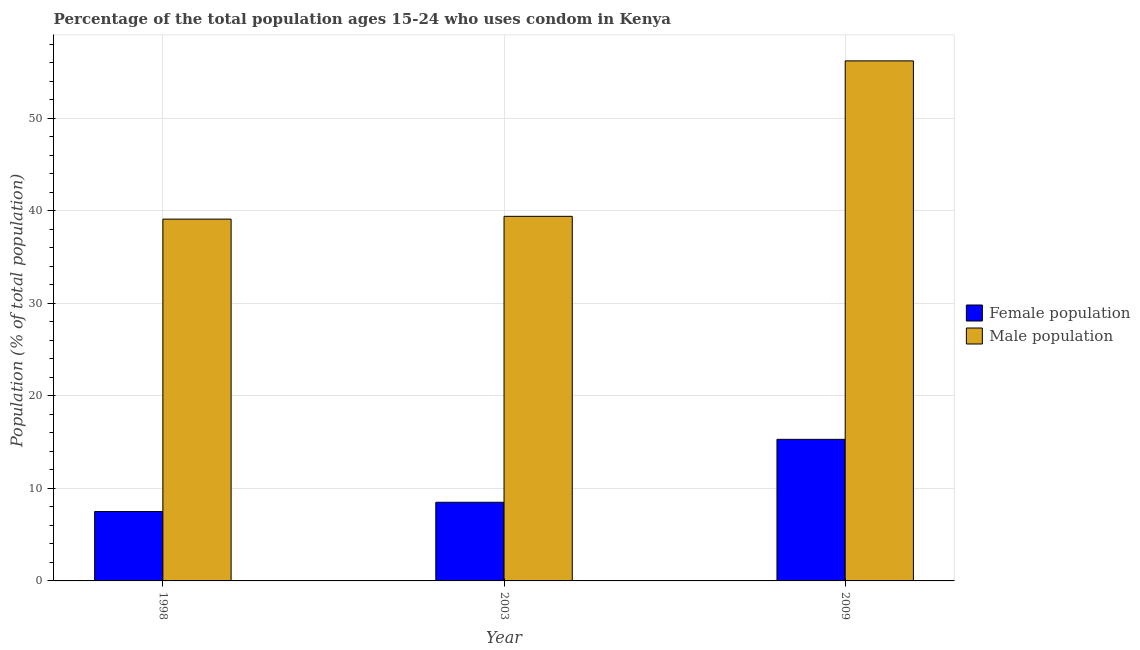Are the number of bars on each tick of the X-axis equal?
Provide a short and direct response. Yes. How many bars are there on the 1st tick from the left?
Your answer should be very brief. 2. What is the label of the 1st group of bars from the left?
Make the answer very short. 1998. In how many cases, is the number of bars for a given year not equal to the number of legend labels?
Provide a short and direct response. 0. What is the female population in 1998?
Give a very brief answer. 7.5. Across all years, what is the maximum male population?
Your answer should be very brief. 56.2. Across all years, what is the minimum male population?
Give a very brief answer. 39.1. In which year was the female population maximum?
Your answer should be compact. 2009. What is the total female population in the graph?
Keep it short and to the point. 31.3. What is the difference between the male population in 1998 and that in 2003?
Keep it short and to the point. -0.3. What is the average female population per year?
Provide a short and direct response. 10.43. What is the ratio of the female population in 2003 to that in 2009?
Offer a very short reply. 0.56. Is the difference between the female population in 1998 and 2009 greater than the difference between the male population in 1998 and 2009?
Provide a succinct answer. No. What is the difference between the highest and the second highest female population?
Your answer should be compact. 6.8. What is the difference between the highest and the lowest female population?
Offer a terse response. 7.8. What does the 1st bar from the left in 2009 represents?
Provide a short and direct response. Female population. What does the 2nd bar from the right in 2009 represents?
Keep it short and to the point. Female population. How many bars are there?
Your answer should be compact. 6. Are the values on the major ticks of Y-axis written in scientific E-notation?
Make the answer very short. No. Where does the legend appear in the graph?
Make the answer very short. Center right. What is the title of the graph?
Give a very brief answer. Percentage of the total population ages 15-24 who uses condom in Kenya. Does "Netherlands" appear as one of the legend labels in the graph?
Give a very brief answer. No. What is the label or title of the X-axis?
Offer a terse response. Year. What is the label or title of the Y-axis?
Provide a short and direct response. Population (% of total population) . What is the Population (% of total population)  of Male population in 1998?
Ensure brevity in your answer.  39.1. What is the Population (% of total population)  in Male population in 2003?
Your answer should be compact. 39.4. What is the Population (% of total population)  in Female population in 2009?
Give a very brief answer. 15.3. What is the Population (% of total population)  in Male population in 2009?
Your response must be concise. 56.2. Across all years, what is the maximum Population (% of total population)  in Male population?
Offer a terse response. 56.2. Across all years, what is the minimum Population (% of total population)  in Female population?
Ensure brevity in your answer.  7.5. Across all years, what is the minimum Population (% of total population)  in Male population?
Your response must be concise. 39.1. What is the total Population (% of total population)  in Female population in the graph?
Give a very brief answer. 31.3. What is the total Population (% of total population)  of Male population in the graph?
Your answer should be compact. 134.7. What is the difference between the Population (% of total population)  in Male population in 1998 and that in 2009?
Give a very brief answer. -17.1. What is the difference between the Population (% of total population)  of Female population in 2003 and that in 2009?
Keep it short and to the point. -6.8. What is the difference between the Population (% of total population)  of Male population in 2003 and that in 2009?
Offer a very short reply. -16.8. What is the difference between the Population (% of total population)  in Female population in 1998 and the Population (% of total population)  in Male population in 2003?
Offer a very short reply. -31.9. What is the difference between the Population (% of total population)  in Female population in 1998 and the Population (% of total population)  in Male population in 2009?
Make the answer very short. -48.7. What is the difference between the Population (% of total population)  of Female population in 2003 and the Population (% of total population)  of Male population in 2009?
Your answer should be very brief. -47.7. What is the average Population (% of total population)  of Female population per year?
Keep it short and to the point. 10.43. What is the average Population (% of total population)  of Male population per year?
Keep it short and to the point. 44.9. In the year 1998, what is the difference between the Population (% of total population)  in Female population and Population (% of total population)  in Male population?
Give a very brief answer. -31.6. In the year 2003, what is the difference between the Population (% of total population)  in Female population and Population (% of total population)  in Male population?
Offer a terse response. -30.9. In the year 2009, what is the difference between the Population (% of total population)  of Female population and Population (% of total population)  of Male population?
Ensure brevity in your answer.  -40.9. What is the ratio of the Population (% of total population)  of Female population in 1998 to that in 2003?
Offer a terse response. 0.88. What is the ratio of the Population (% of total population)  of Male population in 1998 to that in 2003?
Your answer should be compact. 0.99. What is the ratio of the Population (% of total population)  in Female population in 1998 to that in 2009?
Ensure brevity in your answer.  0.49. What is the ratio of the Population (% of total population)  of Male population in 1998 to that in 2009?
Make the answer very short. 0.7. What is the ratio of the Population (% of total population)  of Female population in 2003 to that in 2009?
Offer a very short reply. 0.56. What is the ratio of the Population (% of total population)  of Male population in 2003 to that in 2009?
Keep it short and to the point. 0.7. What is the difference between the highest and the second highest Population (% of total population)  in Female population?
Your answer should be compact. 6.8. 